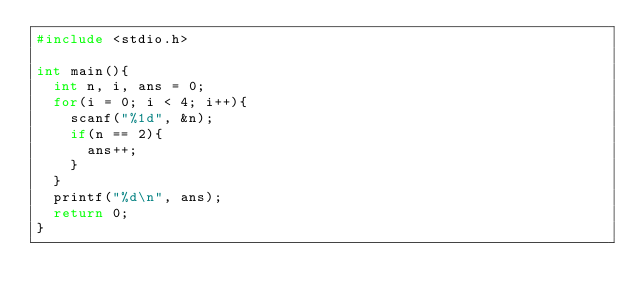Convert code to text. <code><loc_0><loc_0><loc_500><loc_500><_C_>#include <stdio.h>

int main(){
	int n, i, ans = 0;
	for(i = 0; i < 4; i++){
		scanf("%1d", &n);
		if(n == 2){
			ans++;
		}
	}
	printf("%d\n", ans);
	return 0;
}</code> 